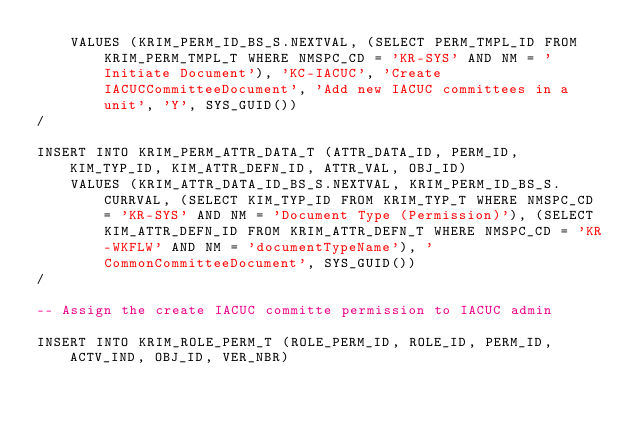<code> <loc_0><loc_0><loc_500><loc_500><_SQL_>    VALUES (KRIM_PERM_ID_BS_S.NEXTVAL, (SELECT PERM_TMPL_ID FROM KRIM_PERM_TMPL_T WHERE NMSPC_CD = 'KR-SYS' AND NM = 'Initiate Document'), 'KC-IACUC', 'Create IACUCCommitteeDocument', 'Add new IACUC committees in a unit', 'Y', SYS_GUID())
/

INSERT INTO KRIM_PERM_ATTR_DATA_T (ATTR_DATA_ID, PERM_ID, KIM_TYP_ID, KIM_ATTR_DEFN_ID, ATTR_VAL, OBJ_ID) 
    VALUES (KRIM_ATTR_DATA_ID_BS_S.NEXTVAL, KRIM_PERM_ID_BS_S.CURRVAL, (SELECT KIM_TYP_ID FROM KRIM_TYP_T WHERE NMSPC_CD = 'KR-SYS' AND NM = 'Document Type (Permission)'), (SELECT KIM_ATTR_DEFN_ID FROM KRIM_ATTR_DEFN_T WHERE NMSPC_CD = 'KR-WKFLW' AND NM = 'documentTypeName'), 'CommonCommitteeDocument', SYS_GUID())
/

-- Assign the create IACUC committe permission to IACUC admin 

INSERT INTO KRIM_ROLE_PERM_T (ROLE_PERM_ID, ROLE_ID, PERM_ID, ACTV_IND, OBJ_ID, VER_NBR) </code> 